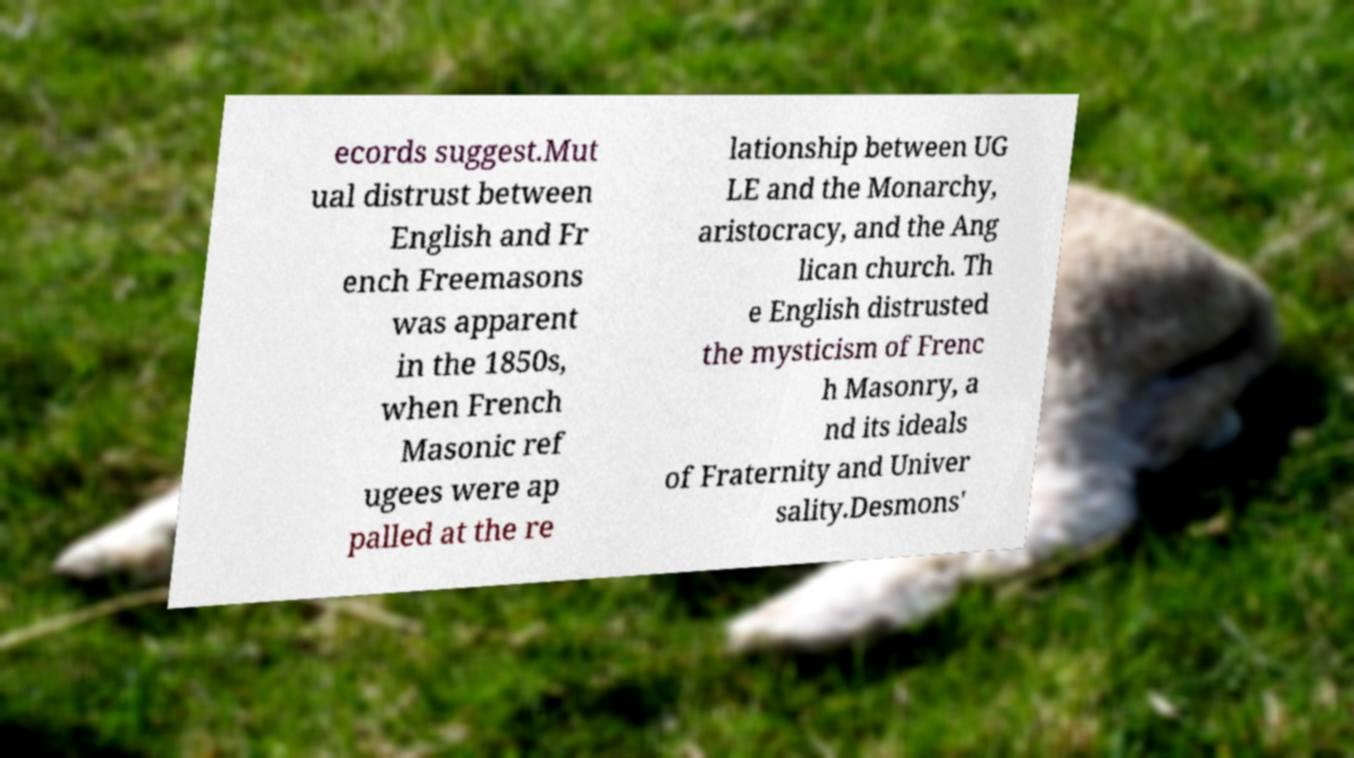What messages or text are displayed in this image? I need them in a readable, typed format. ecords suggest.Mut ual distrust between English and Fr ench Freemasons was apparent in the 1850s, when French Masonic ref ugees were ap palled at the re lationship between UG LE and the Monarchy, aristocracy, and the Ang lican church. Th e English distrusted the mysticism of Frenc h Masonry, a nd its ideals of Fraternity and Univer sality.Desmons' 